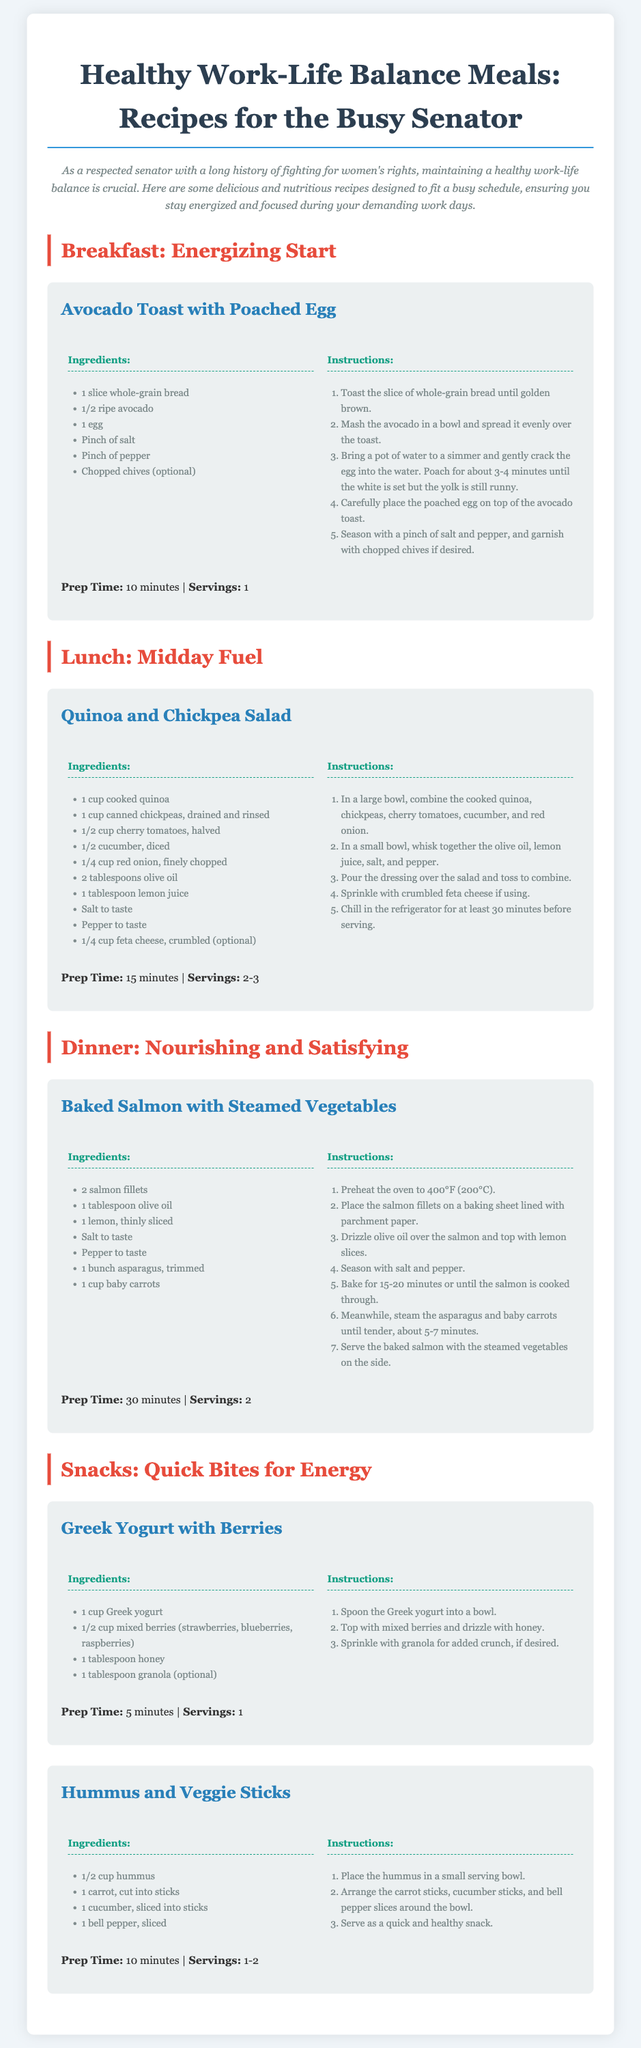What is the title of the document? The title is displayed at the top of the recipe card, indicating the main subject of the content.
Answer: Healthy Work-Life Balance Meals: Recipes for the Busy Senator What is the prep time for the Avocado Toast with Poached Egg? The prep time is listed under the recipe details for the Avocado Toast, indicating how long it takes to prepare.
Answer: 10 minutes How many servings does the Quinoa and Chickpea Salad provide? The number of servings is specified in the recipe section, providing information on how many people the dish can serve.
Answer: 2-3 What ingredient is optional in the Greek Yogurt with Berries recipe? The optional ingredient is mentioned in the list of ingredients for the recipe, noting that it can be included or omitted.
Answer: Granola What is the cooking method for the Salmon in the dinner recipe? The instructions describe how to prepare the salmon, indicating the method used for cooking.
Answer: Baked What dietary benefit does the document aim for with these recipes? The purpose of the recipes relates to promoting a certain lifestyle, addressing a specific need that the document's target audience may have.
Answer: Healthy work-life balance What is included with the Hummus for a quick snack? The snack recipe lists additional items that complement the main ingredient, providing a complete answer.
Answer: Veggie Sticks 